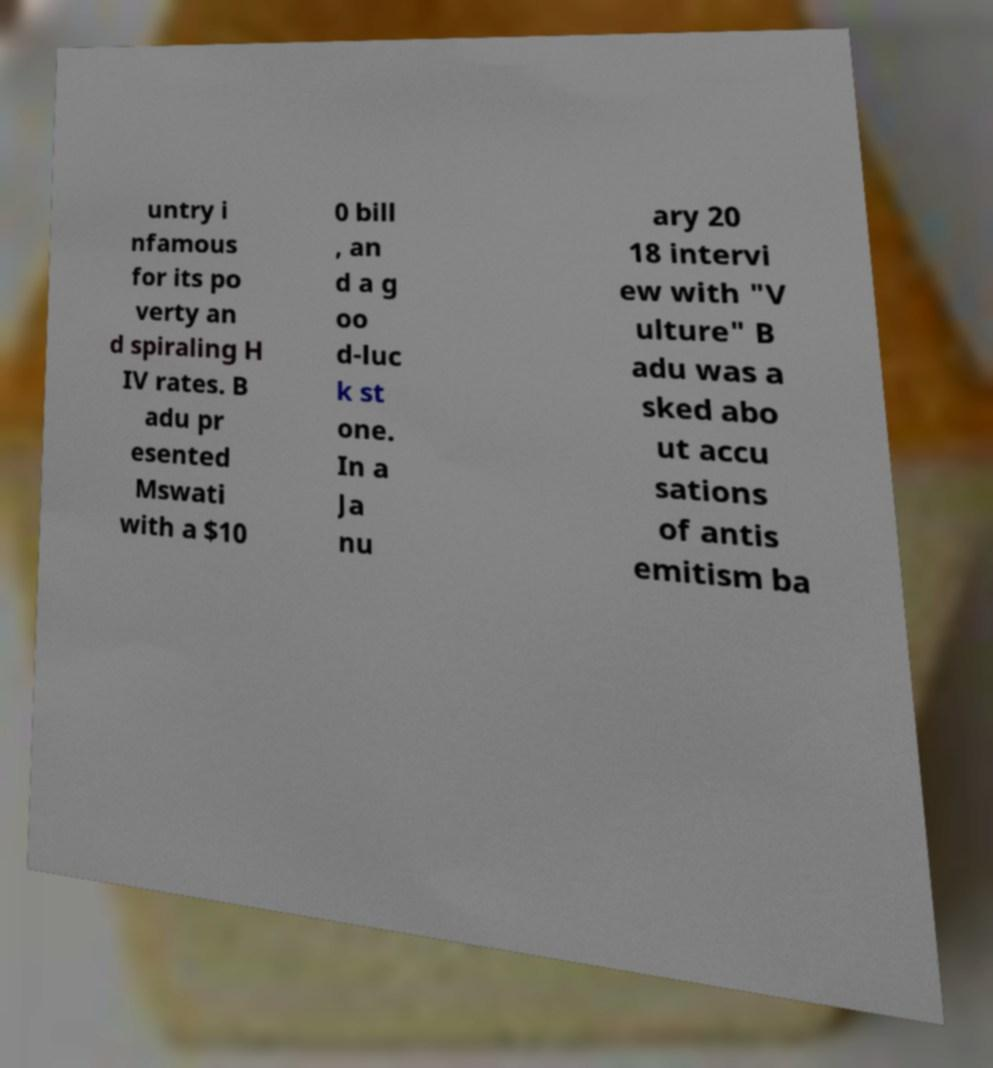Can you read and provide the text displayed in the image?This photo seems to have some interesting text. Can you extract and type it out for me? untry i nfamous for its po verty an d spiraling H IV rates. B adu pr esented Mswati with a $10 0 bill , an d a g oo d-luc k st one. In a Ja nu ary 20 18 intervi ew with "V ulture" B adu was a sked abo ut accu sations of antis emitism ba 